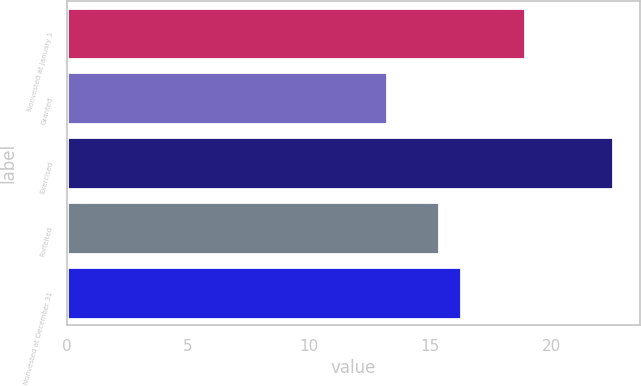Convert chart to OTSL. <chart><loc_0><loc_0><loc_500><loc_500><bar_chart><fcel>Nonvested at January 1<fcel>Granted<fcel>Exercised<fcel>Forfeited<fcel>Nonvested at December 31<nl><fcel>18.89<fcel>13.19<fcel>22.52<fcel>15.34<fcel>16.27<nl></chart> 